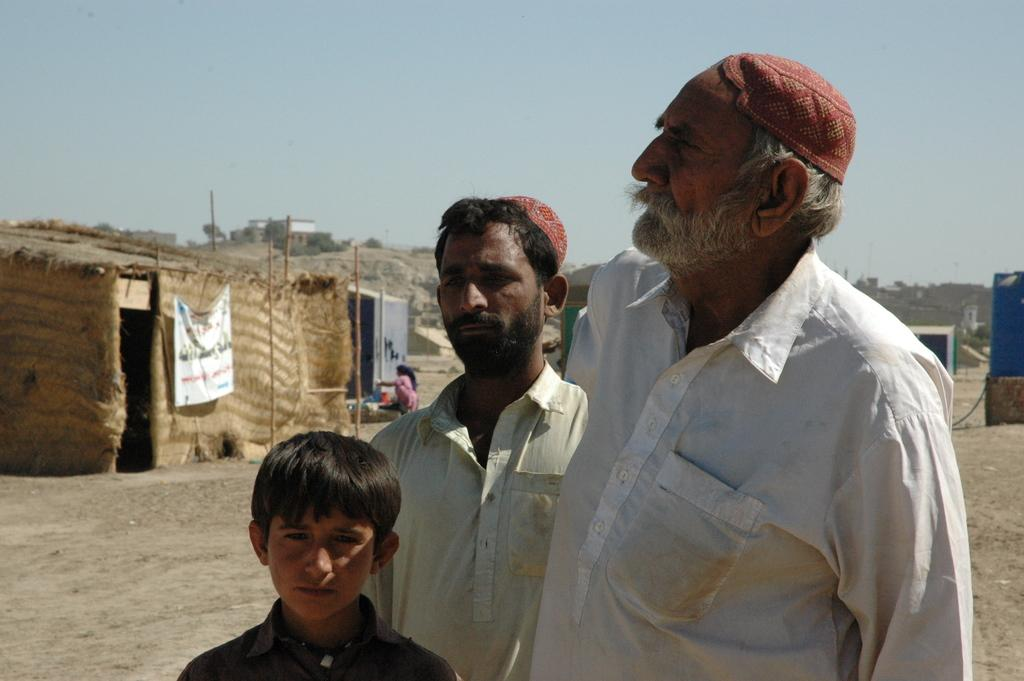Who is present in the image? There is a man in the image. What is the man wearing on his upper body? The man is wearing a white shirt. What type of headwear is the man wearing? The man is wearing a dark red cap. What structure can be seen on the left side of the image? There is a hut on the left side of the image. What is the weather like in the image? The sky is sunny and visible at the top of the image. Can you see any cracks in the man's shirt in the image? There are no visible cracks in the man's shirt in the image. Is the man running in the image? There is no indication that the man is running in the image. 